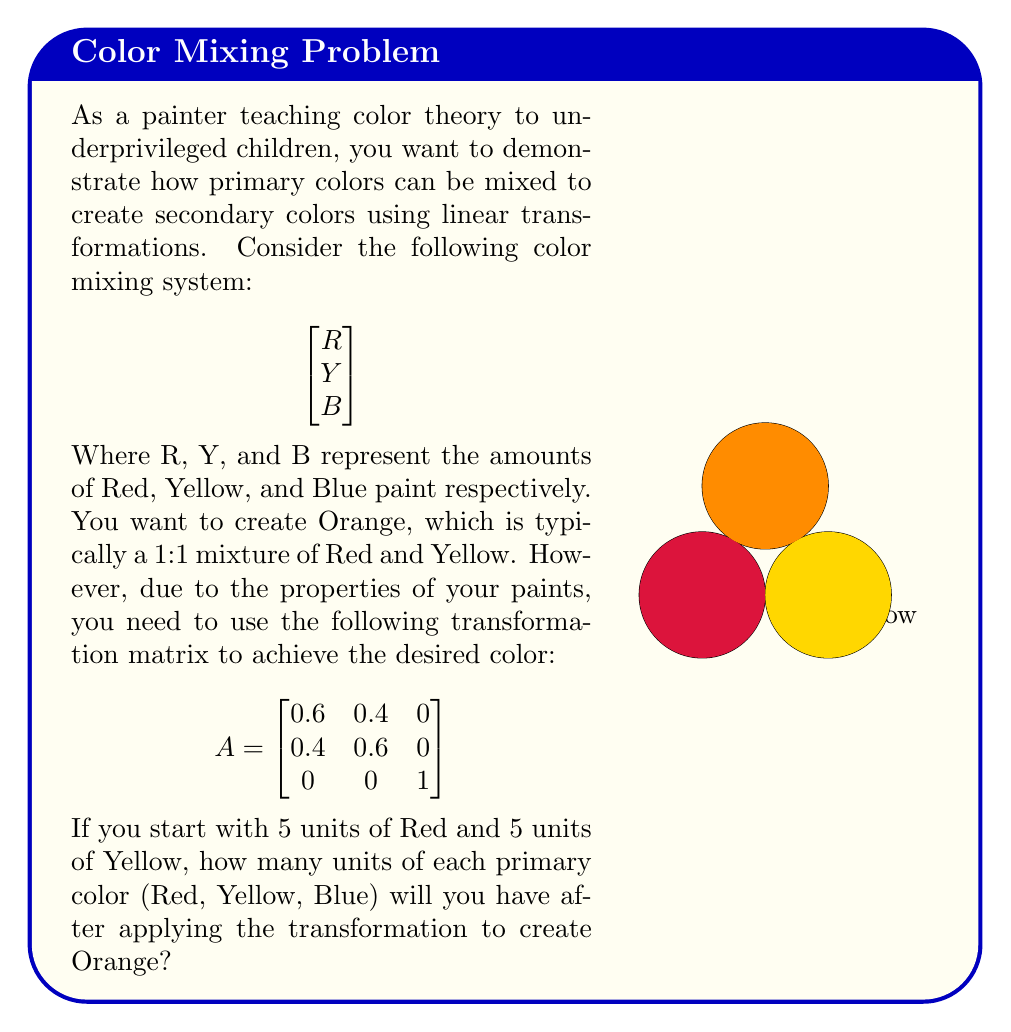Could you help me with this problem? Let's approach this step-by-step:

1) First, we need to represent our initial color mixture as a vector:

   $$\vec{v} = \begin{bmatrix}
   5 \\ 5 \\ 0
   \end{bmatrix}$$

   This represents 5 units of Red, 5 units of Yellow, and 0 units of Blue.

2) To find the new color mixture after the transformation, we need to multiply the transformation matrix A by our initial vector $\vec{v}$:

   $$A\vec{v} = \begin{bmatrix}
   0.6 & 0.4 & 0 \\
   0.4 & 0.6 & 0 \\
   0 & 0 & 1
   \end{bmatrix} \begin{bmatrix}
   5 \\ 5 \\ 0
   \end{bmatrix}$$

3) Let's perform the matrix multiplication:

   $$\begin{bmatrix}
   (0.6 \times 5) + (0.4 \times 5) + (0 \times 0) \\
   (0.4 \times 5) + (0.6 \times 5) + (0 \times 0) \\
   (0 \times 5) + (0 \times 5) + (1 \times 0)
   \end{bmatrix}$$

4) Simplifying:

   $$\begin{bmatrix}
   3 + 2 \\
   2 + 3 \\
   0
   \end{bmatrix} = \begin{bmatrix}
   5 \\ 5 \\ 0
   \end{bmatrix}$$

5) Therefore, after the transformation, we still have 5 units of Red, 5 units of Yellow, and 0 units of Blue. The transformation matrix A effectively redistributed the amounts of Red and Yellow while maintaining their total, creating the desired Orange color.
Answer: $(5, 5, 0)$ 